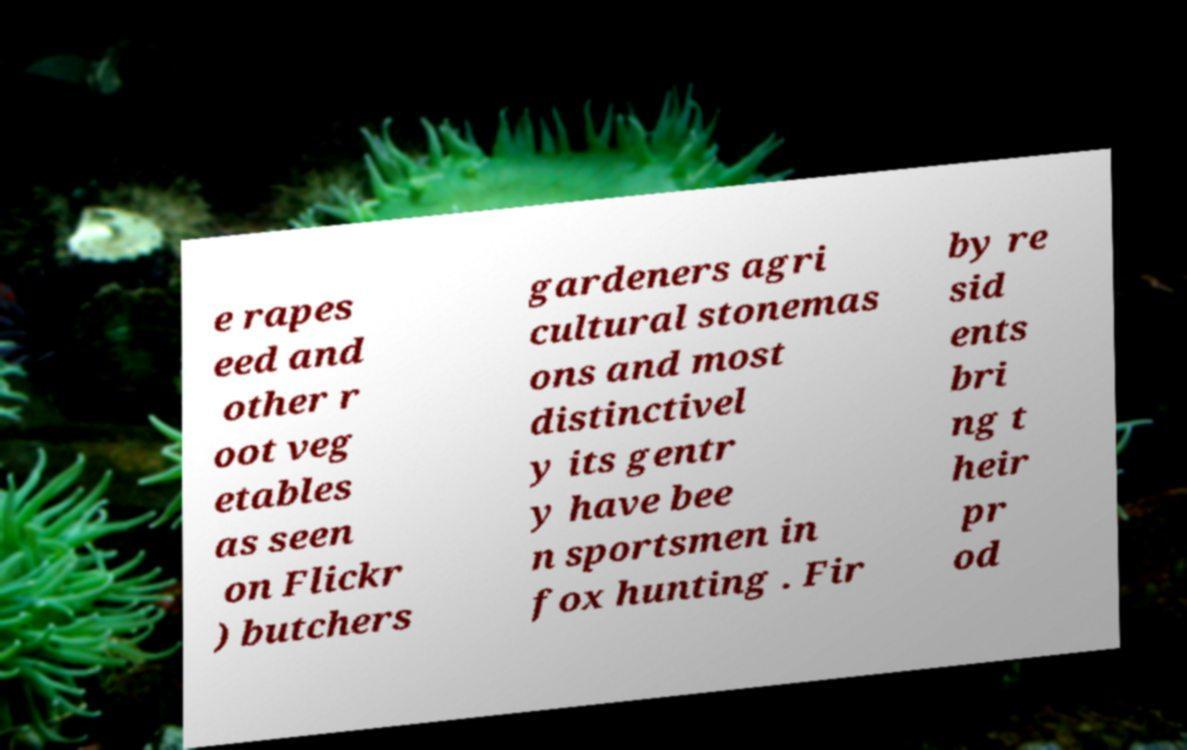Could you assist in decoding the text presented in this image and type it out clearly? e rapes eed and other r oot veg etables as seen on Flickr ) butchers gardeners agri cultural stonemas ons and most distinctivel y its gentr y have bee n sportsmen in fox hunting . Fir by re sid ents bri ng t heir pr od 